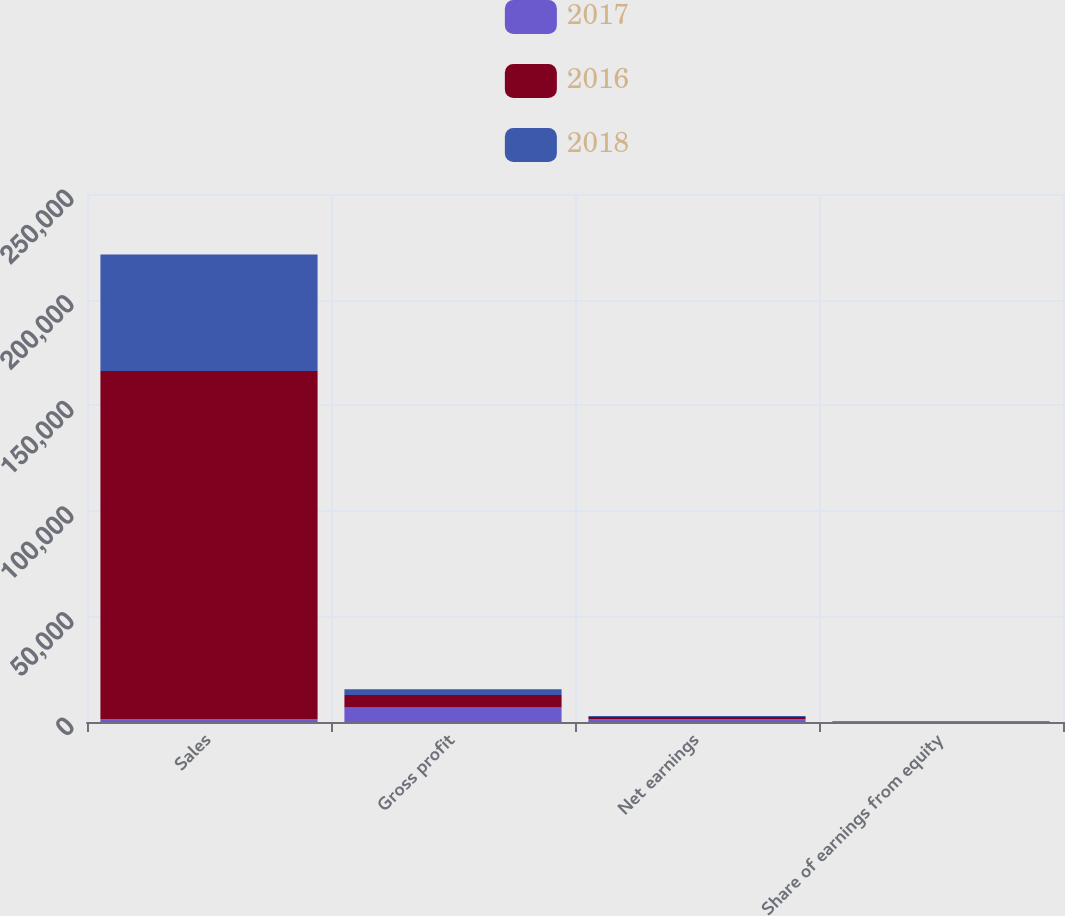Convert chart. <chart><loc_0><loc_0><loc_500><loc_500><stacked_bar_chart><ecel><fcel>Sales<fcel>Gross profit<fcel>Net earnings<fcel>Share of earnings from equity<nl><fcel>2017<fcel>1315<fcel>6875<fcel>1315<fcel>245<nl><fcel>2016<fcel>164844<fcel>5958<fcel>1040<fcel>143<nl><fcel>2018<fcel>55153<fcel>2672<fcel>534<fcel>81<nl></chart> 